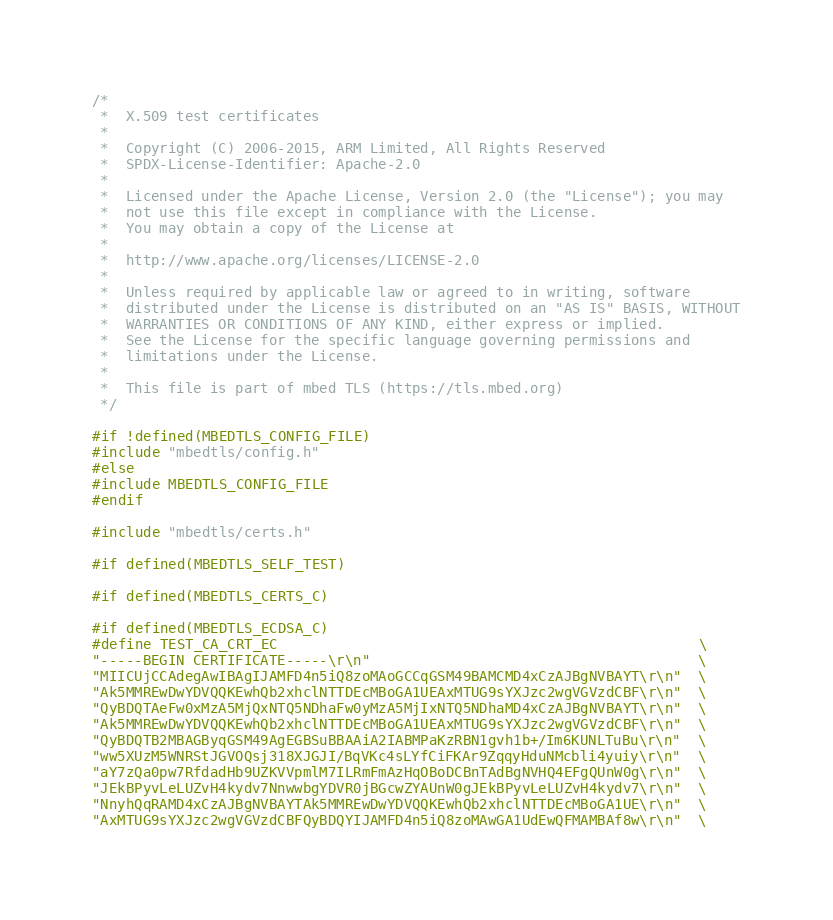<code> <loc_0><loc_0><loc_500><loc_500><_C_>/*
 *  X.509 test certificates
 *
 *  Copyright (C) 2006-2015, ARM Limited, All Rights Reserved
 *  SPDX-License-Identifier: Apache-2.0
 *
 *  Licensed under the Apache License, Version 2.0 (the "License"); you may
 *  not use this file except in compliance with the License.
 *  You may obtain a copy of the License at
 *
 *  http://www.apache.org/licenses/LICENSE-2.0
 *
 *  Unless required by applicable law or agreed to in writing, software
 *  distributed under the License is distributed on an "AS IS" BASIS, WITHOUT
 *  WARRANTIES OR CONDITIONS OF ANY KIND, either express or implied.
 *  See the License for the specific language governing permissions and
 *  limitations under the License.
 *
 *  This file is part of mbed TLS (https://tls.mbed.org)
 */

#if !defined(MBEDTLS_CONFIG_FILE)
#include "mbedtls/config.h"
#else
#include MBEDTLS_CONFIG_FILE
#endif

#include "mbedtls/certs.h"

#if defined(MBEDTLS_SELF_TEST)

#if defined(MBEDTLS_CERTS_C)

#if defined(MBEDTLS_ECDSA_C)
#define TEST_CA_CRT_EC                                                  \
"-----BEGIN CERTIFICATE-----\r\n"                                       \
"MIICUjCCAdegAwIBAgIJAMFD4n5iQ8zoMAoGCCqGSM49BAMCMD4xCzAJBgNVBAYT\r\n"  \
"Ak5MMREwDwYDVQQKEwhQb2xhclNTTDEcMBoGA1UEAxMTUG9sYXJzc2wgVGVzdCBF\r\n"  \
"QyBDQTAeFw0xMzA5MjQxNTQ5NDhaFw0yMzA5MjIxNTQ5NDhaMD4xCzAJBgNVBAYT\r\n"  \
"Ak5MMREwDwYDVQQKEwhQb2xhclNTTDEcMBoGA1UEAxMTUG9sYXJzc2wgVGVzdCBF\r\n"  \
"QyBDQTB2MBAGByqGSM49AgEGBSuBBAAiA2IABMPaKzRBN1gvh1b+/Im6KUNLTuBu\r\n"  \
"ww5XUzM5WNRStJGVOQsj318XJGJI/BqVKc4sLYfCiFKAr9ZqqyHduNMcbli4yuiy\r\n"  \
"aY7zQa0pw7RfdadHb9UZKVVpmlM7ILRmFmAzHqOBoDCBnTAdBgNVHQ4EFgQUnW0g\r\n"  \
"JEkBPyvLeLUZvH4kydv7NnwwbgYDVR0jBGcwZYAUnW0gJEkBPyvLeLUZvH4kydv7\r\n"  \
"NnyhQqRAMD4xCzAJBgNVBAYTAk5MMREwDwYDVQQKEwhQb2xhclNTTDEcMBoGA1UE\r\n"  \
"AxMTUG9sYXJzc2wgVGVzdCBFQyBDQYIJAMFD4n5iQ8zoMAwGA1UdEwQFMAMBAf8w\r\n"  \</code> 